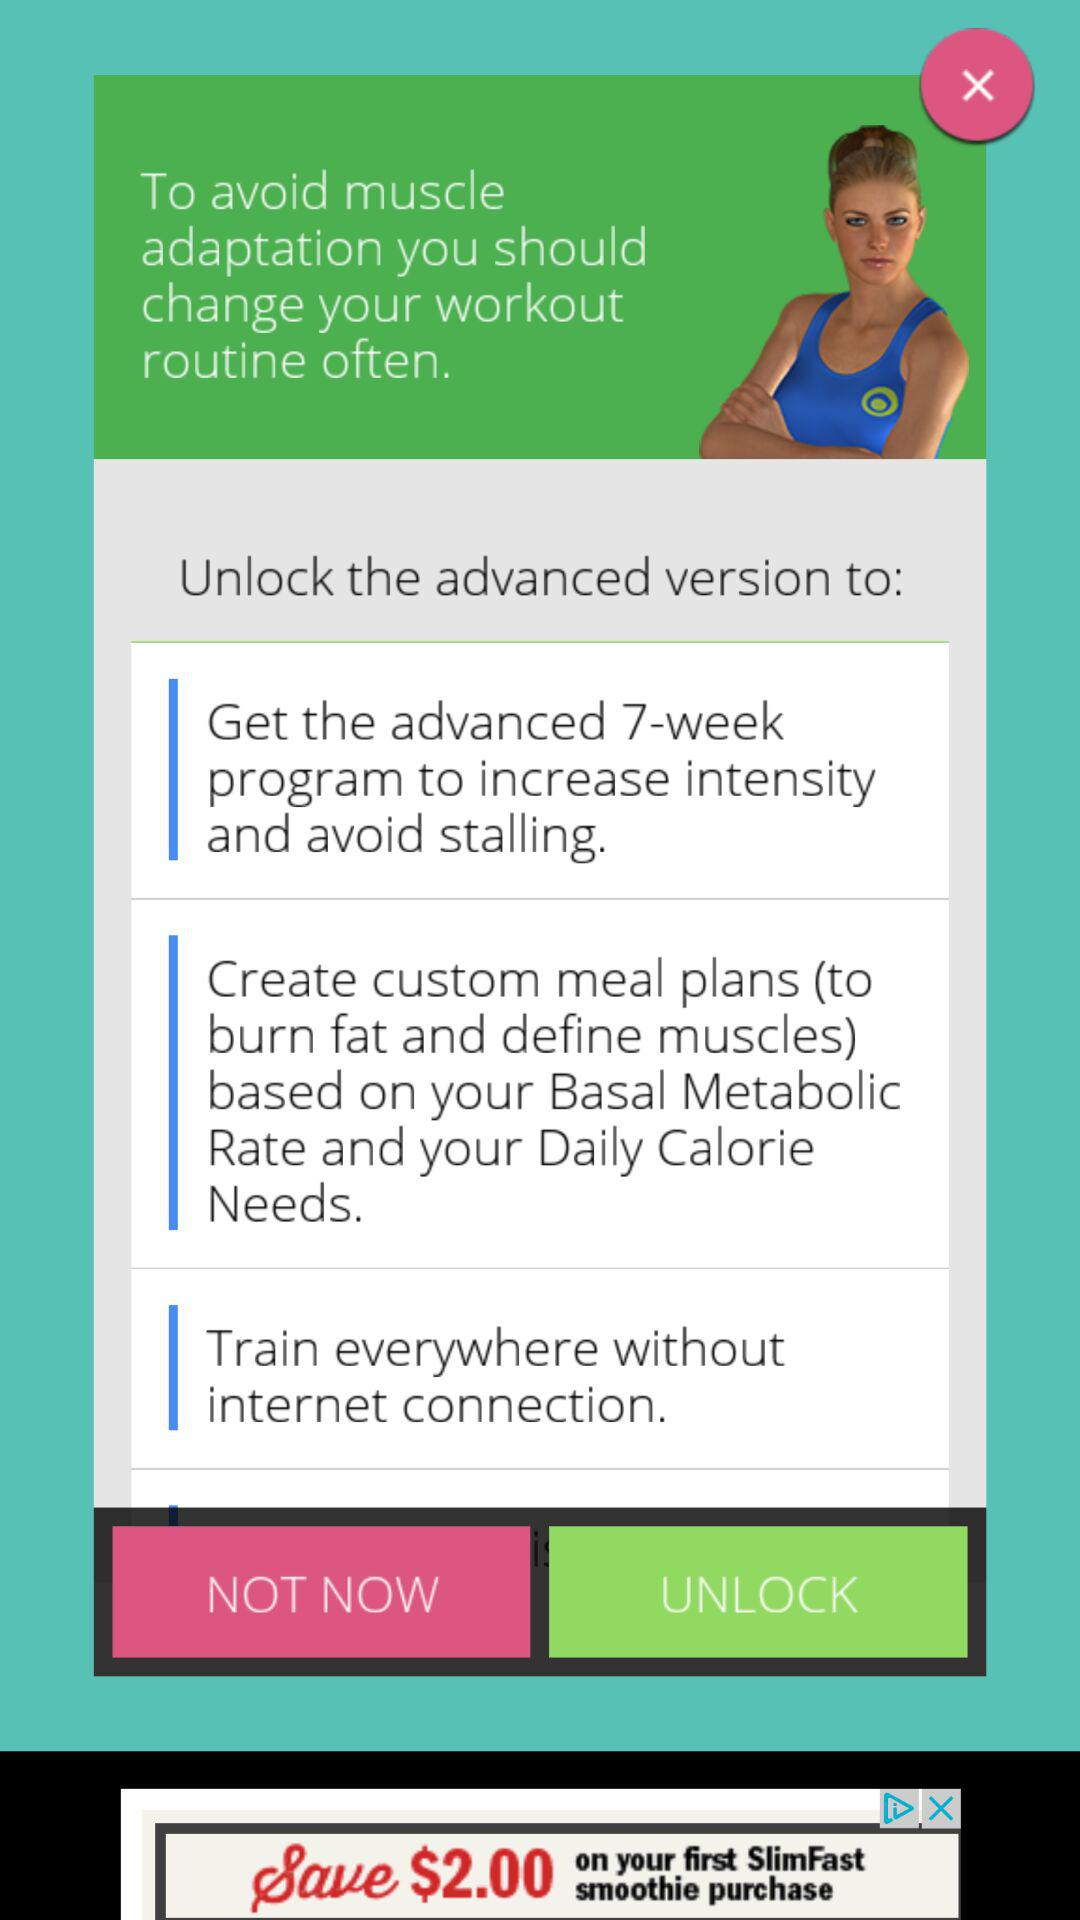How many features can you use without an internet connection?
Answer the question using a single word or phrase. 1 